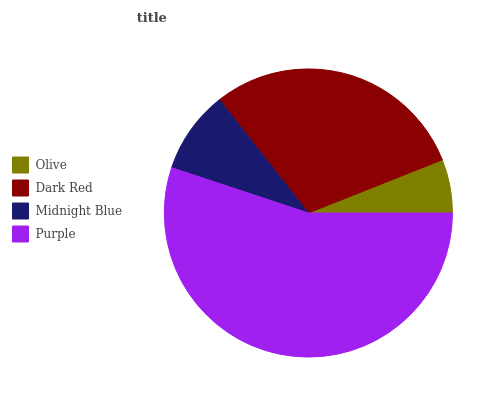Is Olive the minimum?
Answer yes or no. Yes. Is Purple the maximum?
Answer yes or no. Yes. Is Dark Red the minimum?
Answer yes or no. No. Is Dark Red the maximum?
Answer yes or no. No. Is Dark Red greater than Olive?
Answer yes or no. Yes. Is Olive less than Dark Red?
Answer yes or no. Yes. Is Olive greater than Dark Red?
Answer yes or no. No. Is Dark Red less than Olive?
Answer yes or no. No. Is Dark Red the high median?
Answer yes or no. Yes. Is Midnight Blue the low median?
Answer yes or no. Yes. Is Olive the high median?
Answer yes or no. No. Is Purple the low median?
Answer yes or no. No. 